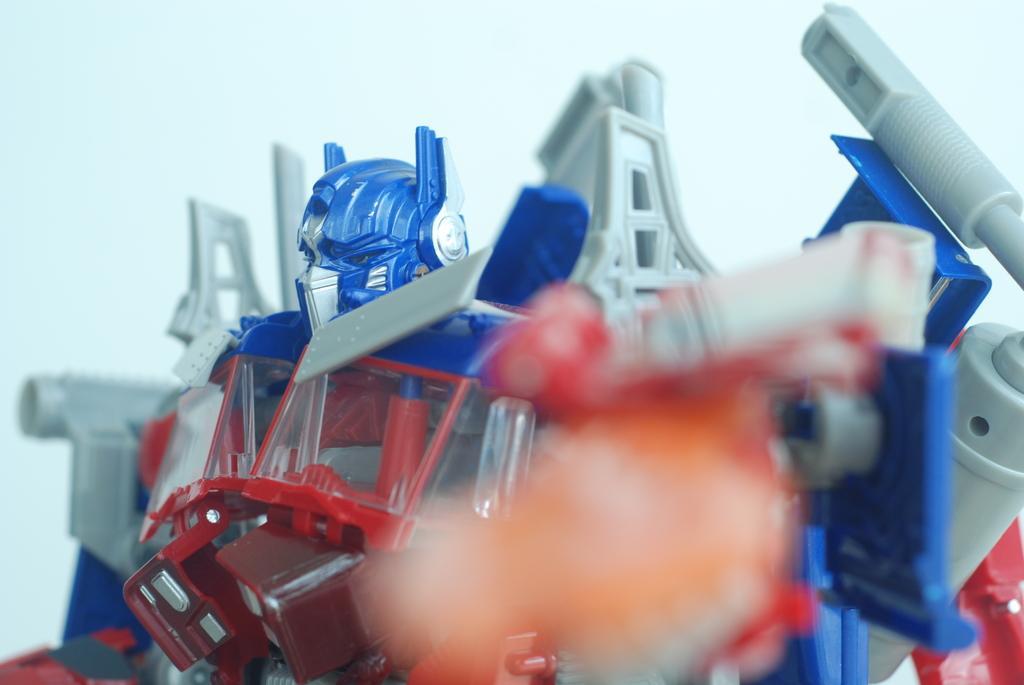Could you give a brief overview of what you see in this image? In the image we can see a toy robot and the background is white in color. 